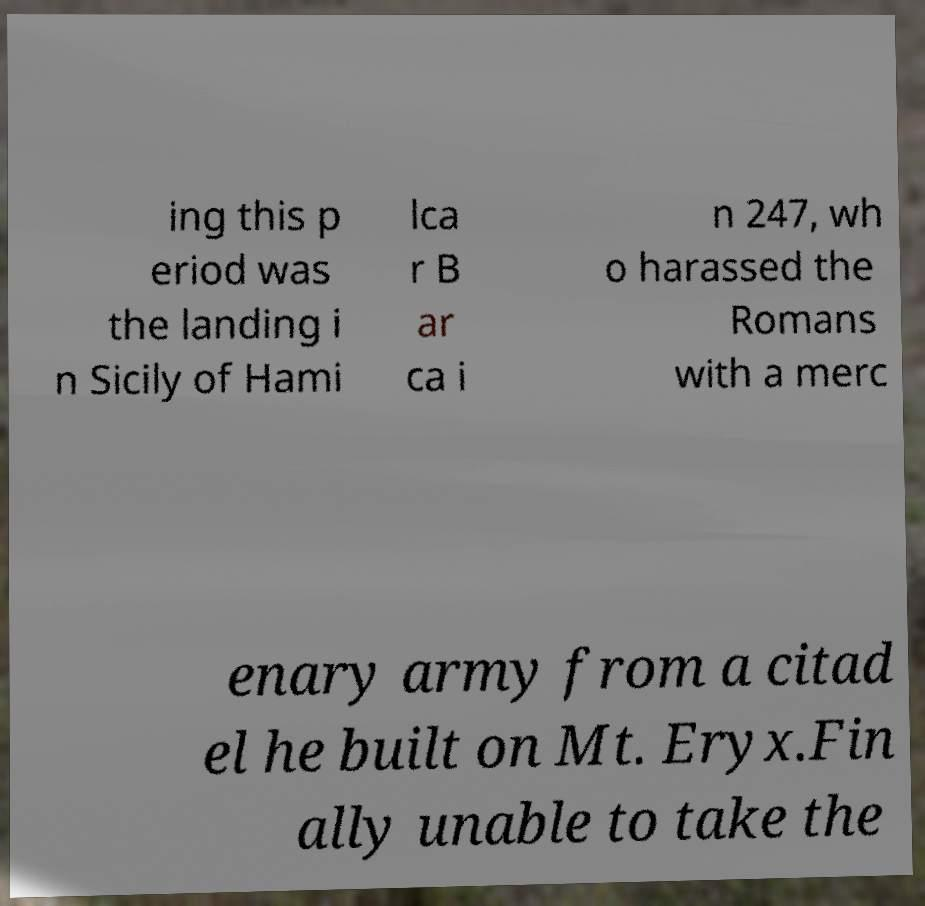What messages or text are displayed in this image? I need them in a readable, typed format. ing this p eriod was the landing i n Sicily of Hami lca r B ar ca i n 247, wh o harassed the Romans with a merc enary army from a citad el he built on Mt. Eryx.Fin ally unable to take the 